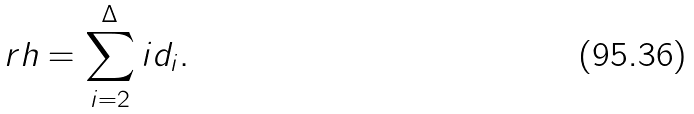<formula> <loc_0><loc_0><loc_500><loc_500>r h = \sum _ { i = 2 } ^ { \Delta } i d _ { i } .</formula> 